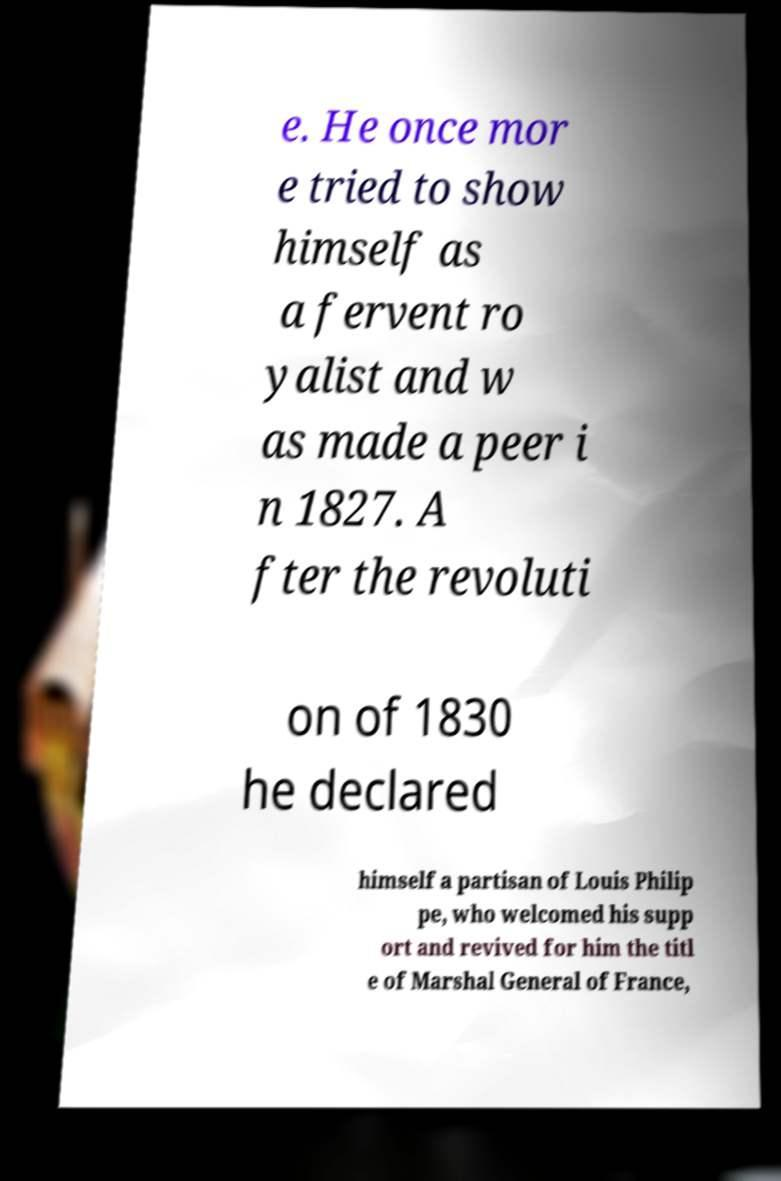Please identify and transcribe the text found in this image. e. He once mor e tried to show himself as a fervent ro yalist and w as made a peer i n 1827. A fter the revoluti on of 1830 he declared himself a partisan of Louis Philip pe, who welcomed his supp ort and revived for him the titl e of Marshal General of France, 